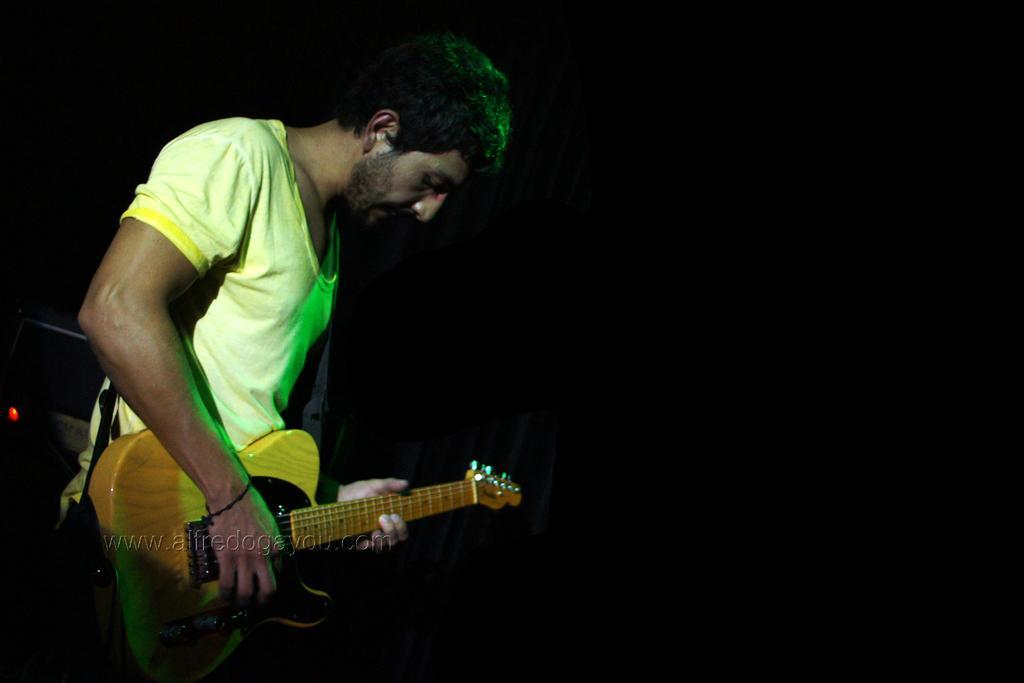Can you describe this image briefly? This picture shows this picture shows a man standing and playing guitar 